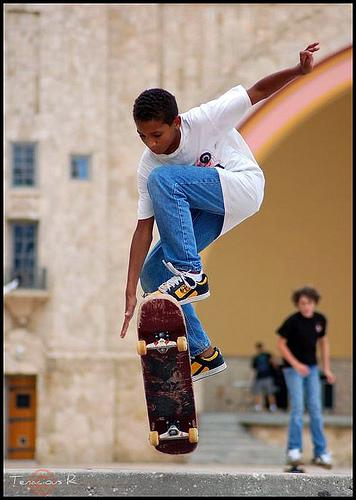Question: who is riding the skateboards?
Choices:
A. The teenagers.
B. The girls.
C. The adults.
D. The boys.
Answer with the letter. Answer: D Question: how many people are visible?
Choices:
A. Two.
B. Three.
C. One.
D. Four.
Answer with the letter. Answer: B Question: how many doors and windows are visible?
Choices:
A. Four.
B. Three.
C. Five.
D. Six.
Answer with the letter. Answer: A Question: why is the boy in the air?
Choices:
A. He just got stung.
B. He's happy.
C. He's dunking.
D. He jumped.
Answer with the letter. Answer: D 